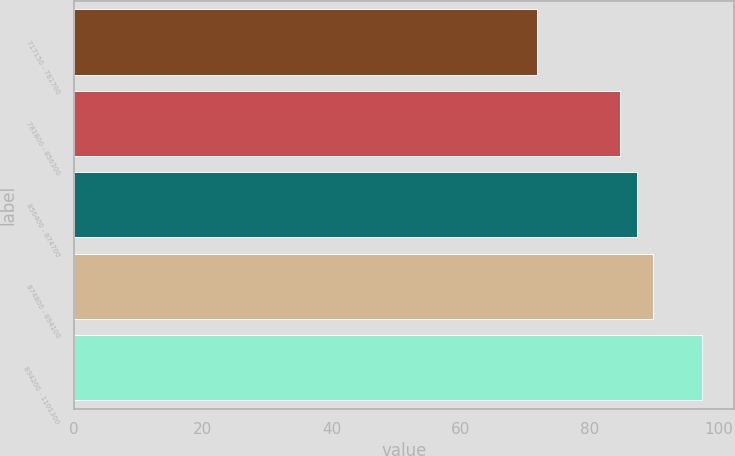<chart> <loc_0><loc_0><loc_500><loc_500><bar_chart><fcel>717150 - 781700<fcel>781800 - 856300<fcel>856400 - 874700<fcel>874800 - 894100<fcel>894200 - 1101300<nl><fcel>71.72<fcel>84.63<fcel>87.2<fcel>89.77<fcel>97.41<nl></chart> 